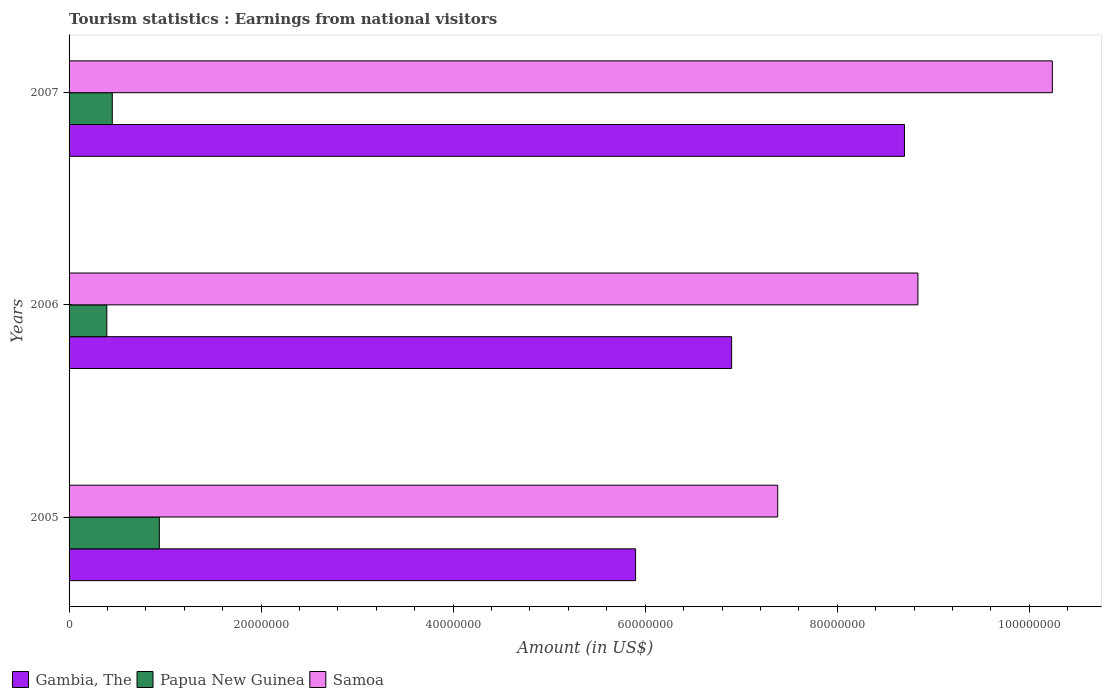How many groups of bars are there?
Ensure brevity in your answer.  3. In how many cases, is the number of bars for a given year not equal to the number of legend labels?
Ensure brevity in your answer.  0. What is the earnings from national visitors in Gambia, The in 2007?
Offer a terse response. 8.70e+07. Across all years, what is the maximum earnings from national visitors in Papua New Guinea?
Make the answer very short. 9.40e+06. Across all years, what is the minimum earnings from national visitors in Samoa?
Keep it short and to the point. 7.38e+07. In which year was the earnings from national visitors in Papua New Guinea minimum?
Your answer should be very brief. 2006. What is the total earnings from national visitors in Papua New Guinea in the graph?
Make the answer very short. 1.78e+07. What is the difference between the earnings from national visitors in Gambia, The in 2005 and that in 2007?
Make the answer very short. -2.80e+07. What is the difference between the earnings from national visitors in Gambia, The in 2006 and the earnings from national visitors in Samoa in 2007?
Ensure brevity in your answer.  -3.34e+07. What is the average earnings from national visitors in Samoa per year?
Provide a succinct answer. 8.82e+07. In the year 2005, what is the difference between the earnings from national visitors in Samoa and earnings from national visitors in Gambia, The?
Your answer should be compact. 1.48e+07. What is the ratio of the earnings from national visitors in Samoa in 2006 to that in 2007?
Keep it short and to the point. 0.86. Is the earnings from national visitors in Gambia, The in 2006 less than that in 2007?
Offer a very short reply. Yes. Is the difference between the earnings from national visitors in Samoa in 2006 and 2007 greater than the difference between the earnings from national visitors in Gambia, The in 2006 and 2007?
Your answer should be very brief. Yes. What is the difference between the highest and the second highest earnings from national visitors in Gambia, The?
Your answer should be very brief. 1.80e+07. What is the difference between the highest and the lowest earnings from national visitors in Papua New Guinea?
Keep it short and to the point. 5.47e+06. In how many years, is the earnings from national visitors in Gambia, The greater than the average earnings from national visitors in Gambia, The taken over all years?
Offer a terse response. 1. What does the 2nd bar from the top in 2007 represents?
Offer a very short reply. Papua New Guinea. What does the 2nd bar from the bottom in 2007 represents?
Your answer should be very brief. Papua New Guinea. How many bars are there?
Provide a succinct answer. 9. How many years are there in the graph?
Give a very brief answer. 3. Where does the legend appear in the graph?
Your answer should be compact. Bottom left. How many legend labels are there?
Provide a short and direct response. 3. What is the title of the graph?
Keep it short and to the point. Tourism statistics : Earnings from national visitors. What is the Amount (in US$) in Gambia, The in 2005?
Give a very brief answer. 5.90e+07. What is the Amount (in US$) of Papua New Guinea in 2005?
Ensure brevity in your answer.  9.40e+06. What is the Amount (in US$) in Samoa in 2005?
Offer a very short reply. 7.38e+07. What is the Amount (in US$) of Gambia, The in 2006?
Your response must be concise. 6.90e+07. What is the Amount (in US$) of Papua New Guinea in 2006?
Ensure brevity in your answer.  3.93e+06. What is the Amount (in US$) in Samoa in 2006?
Offer a very short reply. 8.84e+07. What is the Amount (in US$) of Gambia, The in 2007?
Ensure brevity in your answer.  8.70e+07. What is the Amount (in US$) of Papua New Guinea in 2007?
Your response must be concise. 4.50e+06. What is the Amount (in US$) in Samoa in 2007?
Make the answer very short. 1.02e+08. Across all years, what is the maximum Amount (in US$) in Gambia, The?
Your answer should be compact. 8.70e+07. Across all years, what is the maximum Amount (in US$) of Papua New Guinea?
Offer a terse response. 9.40e+06. Across all years, what is the maximum Amount (in US$) in Samoa?
Keep it short and to the point. 1.02e+08. Across all years, what is the minimum Amount (in US$) of Gambia, The?
Ensure brevity in your answer.  5.90e+07. Across all years, what is the minimum Amount (in US$) of Papua New Guinea?
Your response must be concise. 3.93e+06. Across all years, what is the minimum Amount (in US$) of Samoa?
Offer a very short reply. 7.38e+07. What is the total Amount (in US$) in Gambia, The in the graph?
Provide a short and direct response. 2.15e+08. What is the total Amount (in US$) in Papua New Guinea in the graph?
Offer a terse response. 1.78e+07. What is the total Amount (in US$) of Samoa in the graph?
Make the answer very short. 2.65e+08. What is the difference between the Amount (in US$) in Gambia, The in 2005 and that in 2006?
Your answer should be very brief. -1.00e+07. What is the difference between the Amount (in US$) of Papua New Guinea in 2005 and that in 2006?
Keep it short and to the point. 5.47e+06. What is the difference between the Amount (in US$) of Samoa in 2005 and that in 2006?
Keep it short and to the point. -1.46e+07. What is the difference between the Amount (in US$) in Gambia, The in 2005 and that in 2007?
Offer a very short reply. -2.80e+07. What is the difference between the Amount (in US$) in Papua New Guinea in 2005 and that in 2007?
Your answer should be very brief. 4.90e+06. What is the difference between the Amount (in US$) in Samoa in 2005 and that in 2007?
Provide a short and direct response. -2.86e+07. What is the difference between the Amount (in US$) in Gambia, The in 2006 and that in 2007?
Your answer should be very brief. -1.80e+07. What is the difference between the Amount (in US$) of Papua New Guinea in 2006 and that in 2007?
Your response must be concise. -5.70e+05. What is the difference between the Amount (in US$) in Samoa in 2006 and that in 2007?
Give a very brief answer. -1.40e+07. What is the difference between the Amount (in US$) of Gambia, The in 2005 and the Amount (in US$) of Papua New Guinea in 2006?
Your answer should be very brief. 5.51e+07. What is the difference between the Amount (in US$) in Gambia, The in 2005 and the Amount (in US$) in Samoa in 2006?
Your response must be concise. -2.94e+07. What is the difference between the Amount (in US$) of Papua New Guinea in 2005 and the Amount (in US$) of Samoa in 2006?
Give a very brief answer. -7.90e+07. What is the difference between the Amount (in US$) in Gambia, The in 2005 and the Amount (in US$) in Papua New Guinea in 2007?
Your answer should be very brief. 5.45e+07. What is the difference between the Amount (in US$) in Gambia, The in 2005 and the Amount (in US$) in Samoa in 2007?
Make the answer very short. -4.34e+07. What is the difference between the Amount (in US$) in Papua New Guinea in 2005 and the Amount (in US$) in Samoa in 2007?
Your answer should be compact. -9.30e+07. What is the difference between the Amount (in US$) of Gambia, The in 2006 and the Amount (in US$) of Papua New Guinea in 2007?
Make the answer very short. 6.45e+07. What is the difference between the Amount (in US$) in Gambia, The in 2006 and the Amount (in US$) in Samoa in 2007?
Offer a very short reply. -3.34e+07. What is the difference between the Amount (in US$) in Papua New Guinea in 2006 and the Amount (in US$) in Samoa in 2007?
Ensure brevity in your answer.  -9.85e+07. What is the average Amount (in US$) in Gambia, The per year?
Provide a succinct answer. 7.17e+07. What is the average Amount (in US$) of Papua New Guinea per year?
Make the answer very short. 5.94e+06. What is the average Amount (in US$) in Samoa per year?
Make the answer very short. 8.82e+07. In the year 2005, what is the difference between the Amount (in US$) in Gambia, The and Amount (in US$) in Papua New Guinea?
Your answer should be very brief. 4.96e+07. In the year 2005, what is the difference between the Amount (in US$) of Gambia, The and Amount (in US$) of Samoa?
Keep it short and to the point. -1.48e+07. In the year 2005, what is the difference between the Amount (in US$) in Papua New Guinea and Amount (in US$) in Samoa?
Provide a succinct answer. -6.44e+07. In the year 2006, what is the difference between the Amount (in US$) in Gambia, The and Amount (in US$) in Papua New Guinea?
Your answer should be very brief. 6.51e+07. In the year 2006, what is the difference between the Amount (in US$) of Gambia, The and Amount (in US$) of Samoa?
Provide a succinct answer. -1.94e+07. In the year 2006, what is the difference between the Amount (in US$) in Papua New Guinea and Amount (in US$) in Samoa?
Keep it short and to the point. -8.45e+07. In the year 2007, what is the difference between the Amount (in US$) in Gambia, The and Amount (in US$) in Papua New Guinea?
Your answer should be compact. 8.25e+07. In the year 2007, what is the difference between the Amount (in US$) of Gambia, The and Amount (in US$) of Samoa?
Offer a terse response. -1.54e+07. In the year 2007, what is the difference between the Amount (in US$) of Papua New Guinea and Amount (in US$) of Samoa?
Your response must be concise. -9.79e+07. What is the ratio of the Amount (in US$) of Gambia, The in 2005 to that in 2006?
Provide a short and direct response. 0.86. What is the ratio of the Amount (in US$) of Papua New Guinea in 2005 to that in 2006?
Give a very brief answer. 2.39. What is the ratio of the Amount (in US$) in Samoa in 2005 to that in 2006?
Your answer should be compact. 0.83. What is the ratio of the Amount (in US$) in Gambia, The in 2005 to that in 2007?
Ensure brevity in your answer.  0.68. What is the ratio of the Amount (in US$) of Papua New Guinea in 2005 to that in 2007?
Offer a terse response. 2.09. What is the ratio of the Amount (in US$) in Samoa in 2005 to that in 2007?
Provide a succinct answer. 0.72. What is the ratio of the Amount (in US$) in Gambia, The in 2006 to that in 2007?
Offer a very short reply. 0.79. What is the ratio of the Amount (in US$) of Papua New Guinea in 2006 to that in 2007?
Your answer should be very brief. 0.87. What is the ratio of the Amount (in US$) of Samoa in 2006 to that in 2007?
Ensure brevity in your answer.  0.86. What is the difference between the highest and the second highest Amount (in US$) in Gambia, The?
Provide a succinct answer. 1.80e+07. What is the difference between the highest and the second highest Amount (in US$) of Papua New Guinea?
Your response must be concise. 4.90e+06. What is the difference between the highest and the second highest Amount (in US$) in Samoa?
Give a very brief answer. 1.40e+07. What is the difference between the highest and the lowest Amount (in US$) in Gambia, The?
Provide a succinct answer. 2.80e+07. What is the difference between the highest and the lowest Amount (in US$) in Papua New Guinea?
Ensure brevity in your answer.  5.47e+06. What is the difference between the highest and the lowest Amount (in US$) of Samoa?
Your answer should be compact. 2.86e+07. 